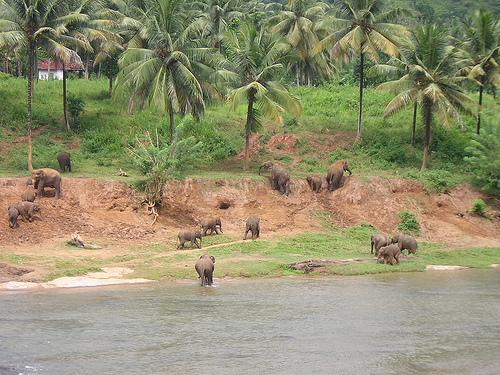Question: when was the picture taken?
Choices:
A. At night.
B. On my birthday.
C. In the daytime.
D. At graduation.
Answer with the letter. Answer: C Question: why are the elephants by the water?
Choices:
A. To drink water.
B. To bathe.
C. Cool off.
D. To cross the river.
Answer with the letter. Answer: A Question: who is in the picture?
Choices:
A. Elephants.
B. Giraffes.
C. Lions.
D. Bears.
Answer with the letter. Answer: A Question: how many elephants are there?
Choices:
A. 1.
B. 2.
C. 15.
D. 3.
Answer with the letter. Answer: C 